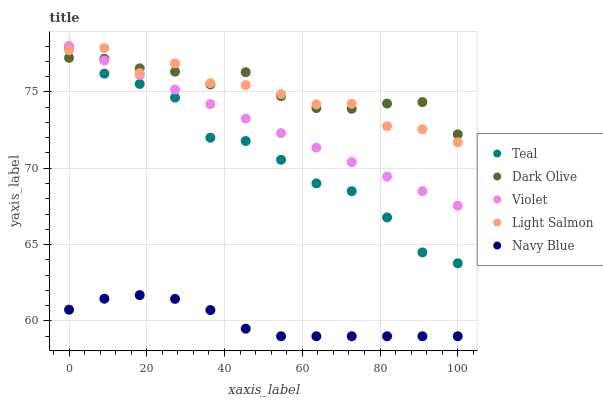Does Navy Blue have the minimum area under the curve?
Answer yes or no. Yes. Does Dark Olive have the maximum area under the curve?
Answer yes or no. Yes. Does Light Salmon have the minimum area under the curve?
Answer yes or no. No. Does Light Salmon have the maximum area under the curve?
Answer yes or no. No. Is Violet the smoothest?
Answer yes or no. Yes. Is Light Salmon the roughest?
Answer yes or no. Yes. Is Dark Olive the smoothest?
Answer yes or no. No. Is Dark Olive the roughest?
Answer yes or no. No. Does Navy Blue have the lowest value?
Answer yes or no. Yes. Does Light Salmon have the lowest value?
Answer yes or no. No. Does Violet have the highest value?
Answer yes or no. Yes. Does Light Salmon have the highest value?
Answer yes or no. No. Is Navy Blue less than Dark Olive?
Answer yes or no. Yes. Is Violet greater than Navy Blue?
Answer yes or no. Yes. Does Light Salmon intersect Teal?
Answer yes or no. Yes. Is Light Salmon less than Teal?
Answer yes or no. No. Is Light Salmon greater than Teal?
Answer yes or no. No. Does Navy Blue intersect Dark Olive?
Answer yes or no. No. 